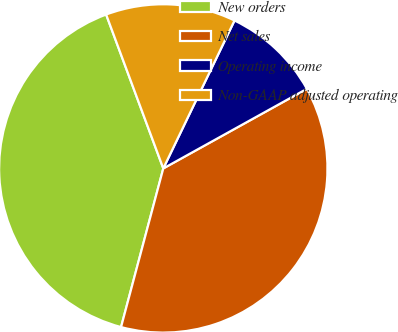<chart> <loc_0><loc_0><loc_500><loc_500><pie_chart><fcel>New orders<fcel>Net sales<fcel>Operating income<fcel>Non-GAAP adjusted operating<nl><fcel>40.2%<fcel>37.2%<fcel>9.8%<fcel>12.8%<nl></chart> 